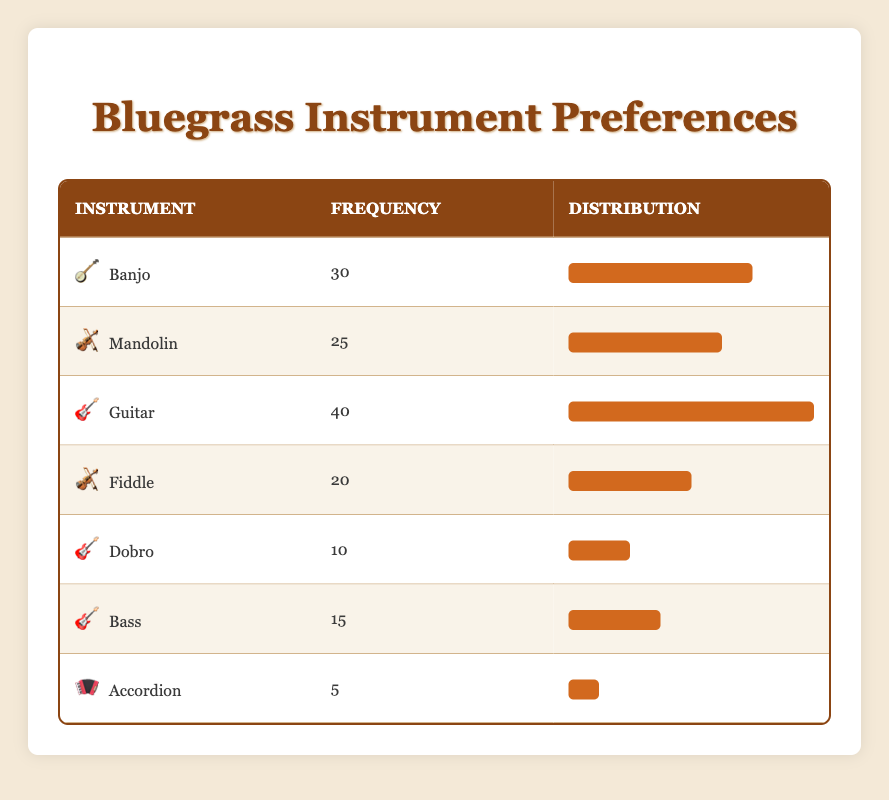What is the most preferred instrument among bluegrass musicians in the region? The instrument with the highest frequency is Guitar, which has a frequency of 40.
Answer: Guitar How many musicians prefer the Banjo? The frequency listed for the Banjo is 30 musicians.
Answer: 30 What is the total number of musicians surveyed for their instrument preferences? To find the total, we need to sum all the frequencies: 30 (Banjo) + 25 (Mandolin) + 40 (Guitar) + 20 (Fiddle) + 10 (Dobro) + 15 (Bass) + 5 (Accordion) = 155.
Answer: 155 Is the frequency of the Fiddle higher than that of the Accordion? The Fiddle has a frequency of 20, while the Accordion has a frequency of 5. Since 20 is greater than 5, the statement is true.
Answer: Yes What instrument has the lowest frequency, and how many musicians prefer it? The Accordion has the lowest frequency at 5 musicians.
Answer: Accordion, 5 What is the average frequency of musical instrument preferences among the bluegrass musicians? We find the average by adding all frequencies (155) and dividing by the number of instruments (7): 155 / 7 ≈ 22.14.
Answer: 22.14 How many musicians prefer the Guitar and Banjo combined? We sum the frequencies of Guitar (40) and Banjo (30): 40 + 30 = 70 musicians.
Answer: 70 Does more than half of the surveyed musicians prefer the Mandolin? More than half would be greater than 77.5 (155/2). The Mandolin frequency is 25, which is less than 77.5, so the statement is false.
Answer: No What is the difference in frequency between the Guitar and the Dobro? The Guitar has a frequency of 40 and the Dobro has a frequency of 10. The difference is 40 - 10 = 30.
Answer: 30 